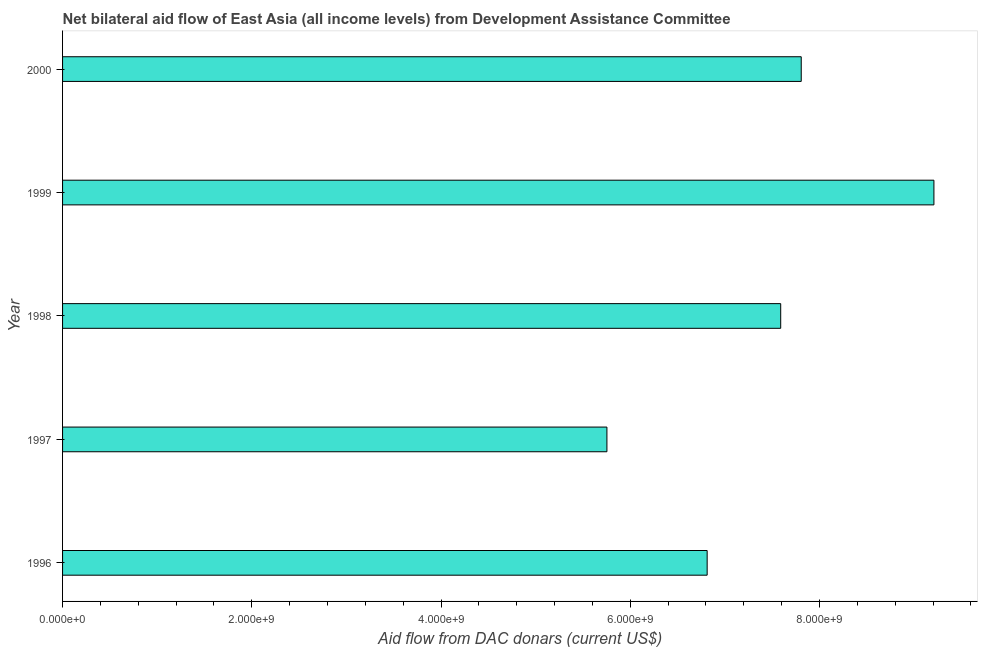What is the title of the graph?
Offer a very short reply. Net bilateral aid flow of East Asia (all income levels) from Development Assistance Committee. What is the label or title of the X-axis?
Offer a terse response. Aid flow from DAC donars (current US$). What is the net bilateral aid flows from dac donors in 1998?
Offer a very short reply. 7.59e+09. Across all years, what is the maximum net bilateral aid flows from dac donors?
Provide a short and direct response. 9.21e+09. Across all years, what is the minimum net bilateral aid flows from dac donors?
Your response must be concise. 5.75e+09. In which year was the net bilateral aid flows from dac donors minimum?
Offer a terse response. 1997. What is the sum of the net bilateral aid flows from dac donors?
Offer a terse response. 3.72e+1. What is the difference between the net bilateral aid flows from dac donors in 1996 and 1998?
Ensure brevity in your answer.  -7.77e+08. What is the average net bilateral aid flows from dac donors per year?
Offer a very short reply. 7.43e+09. What is the median net bilateral aid flows from dac donors?
Ensure brevity in your answer.  7.59e+09. In how many years, is the net bilateral aid flows from dac donors greater than 4400000000 US$?
Provide a short and direct response. 5. Is the net bilateral aid flows from dac donors in 1996 less than that in 2000?
Your response must be concise. Yes. Is the difference between the net bilateral aid flows from dac donors in 1998 and 2000 greater than the difference between any two years?
Provide a succinct answer. No. What is the difference between the highest and the second highest net bilateral aid flows from dac donors?
Your answer should be very brief. 1.40e+09. What is the difference between the highest and the lowest net bilateral aid flows from dac donors?
Your answer should be compact. 3.46e+09. In how many years, is the net bilateral aid flows from dac donors greater than the average net bilateral aid flows from dac donors taken over all years?
Offer a very short reply. 3. Are all the bars in the graph horizontal?
Ensure brevity in your answer.  Yes. What is the Aid flow from DAC donars (current US$) of 1996?
Your response must be concise. 6.81e+09. What is the Aid flow from DAC donars (current US$) in 1997?
Offer a terse response. 5.75e+09. What is the Aid flow from DAC donars (current US$) in 1998?
Offer a terse response. 7.59e+09. What is the Aid flow from DAC donars (current US$) of 1999?
Offer a terse response. 9.21e+09. What is the Aid flow from DAC donars (current US$) in 2000?
Offer a terse response. 7.81e+09. What is the difference between the Aid flow from DAC donars (current US$) in 1996 and 1997?
Offer a terse response. 1.06e+09. What is the difference between the Aid flow from DAC donars (current US$) in 1996 and 1998?
Ensure brevity in your answer.  -7.77e+08. What is the difference between the Aid flow from DAC donars (current US$) in 1996 and 1999?
Make the answer very short. -2.40e+09. What is the difference between the Aid flow from DAC donars (current US$) in 1996 and 2000?
Provide a succinct answer. -9.94e+08. What is the difference between the Aid flow from DAC donars (current US$) in 1997 and 1998?
Provide a succinct answer. -1.84e+09. What is the difference between the Aid flow from DAC donars (current US$) in 1997 and 1999?
Ensure brevity in your answer.  -3.46e+09. What is the difference between the Aid flow from DAC donars (current US$) in 1997 and 2000?
Give a very brief answer. -2.05e+09. What is the difference between the Aid flow from DAC donars (current US$) in 1998 and 1999?
Offer a very short reply. -1.62e+09. What is the difference between the Aid flow from DAC donars (current US$) in 1998 and 2000?
Make the answer very short. -2.17e+08. What is the difference between the Aid flow from DAC donars (current US$) in 1999 and 2000?
Offer a very short reply. 1.40e+09. What is the ratio of the Aid flow from DAC donars (current US$) in 1996 to that in 1997?
Your answer should be compact. 1.18. What is the ratio of the Aid flow from DAC donars (current US$) in 1996 to that in 1998?
Make the answer very short. 0.9. What is the ratio of the Aid flow from DAC donars (current US$) in 1996 to that in 1999?
Provide a short and direct response. 0.74. What is the ratio of the Aid flow from DAC donars (current US$) in 1996 to that in 2000?
Provide a succinct answer. 0.87. What is the ratio of the Aid flow from DAC donars (current US$) in 1997 to that in 1998?
Keep it short and to the point. 0.76. What is the ratio of the Aid flow from DAC donars (current US$) in 1997 to that in 2000?
Offer a terse response. 0.74. What is the ratio of the Aid flow from DAC donars (current US$) in 1998 to that in 1999?
Offer a very short reply. 0.82. What is the ratio of the Aid flow from DAC donars (current US$) in 1998 to that in 2000?
Give a very brief answer. 0.97. What is the ratio of the Aid flow from DAC donars (current US$) in 1999 to that in 2000?
Offer a terse response. 1.18. 